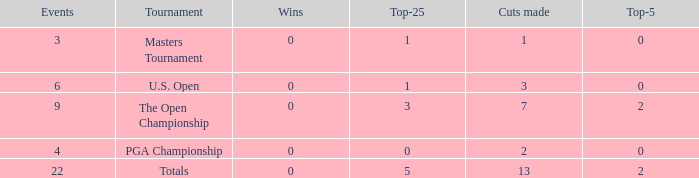What is the average number of cuts made for events with under 4 entries and more than 0 wins? None. 